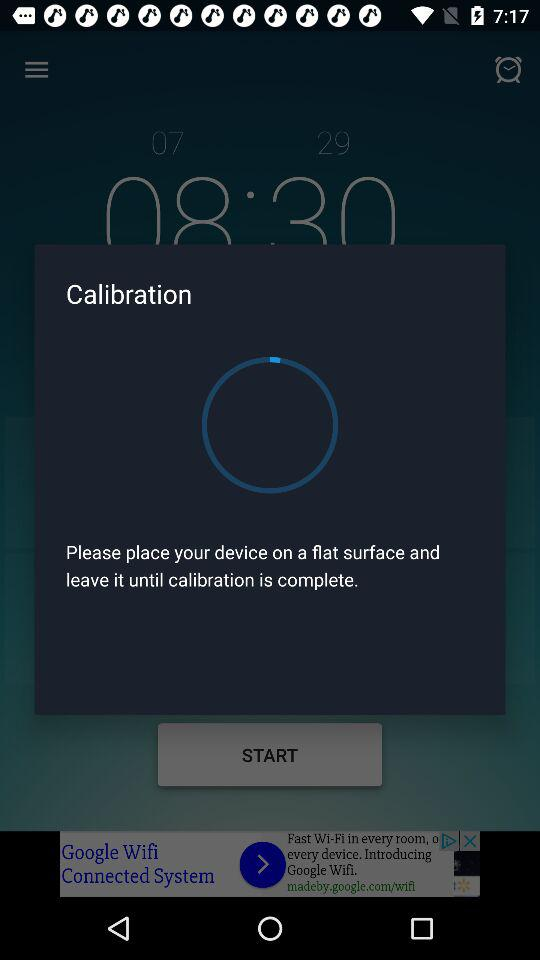What is sleep efficiency? Sleep efficiency is 74%. 